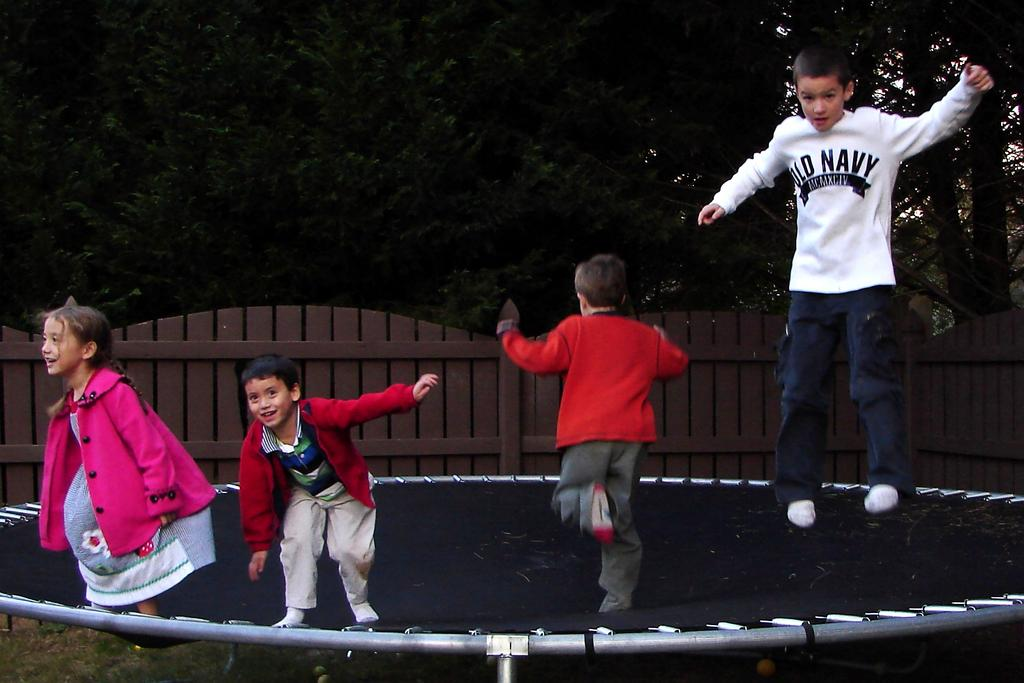What are the people in the image doing? The people are on a trampoline in the image. What color is the trampoline? The trampoline is black in color. What can be seen in the background of the image? There are trees and fencing visible in the background of the image. What type of air can be seen coming out of the bushes in the image? There are no bushes or air visible in the image; it features people on a black trampoline with trees and fencing in the background. 